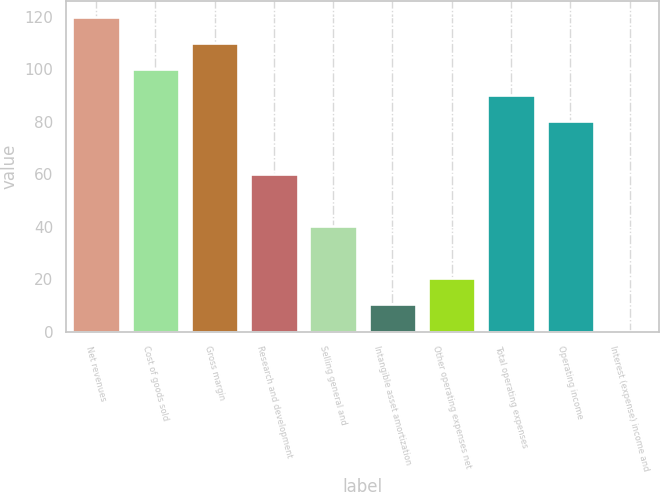<chart> <loc_0><loc_0><loc_500><loc_500><bar_chart><fcel>Net revenues<fcel>Cost of goods sold<fcel>Gross margin<fcel>Research and development<fcel>Selling general and<fcel>Intangible asset amortization<fcel>Other operating expenses net<fcel>Total operating expenses<fcel>Operating income<fcel>Interest (expense) income and<nl><fcel>119.9<fcel>100<fcel>109.95<fcel>60.2<fcel>40.3<fcel>10.45<fcel>20.4<fcel>90.05<fcel>80.1<fcel>0.5<nl></chart> 